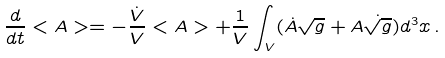Convert formula to latex. <formula><loc_0><loc_0><loc_500><loc_500>\frac { d } { d t } < A > = - \frac { \dot { V } } { V } < A > + \frac { 1 } { V } \int _ { V } ( { \dot { A } } \sqrt { g } + A { \dot { \sqrt { g } } } ) d ^ { 3 } x \, .</formula> 